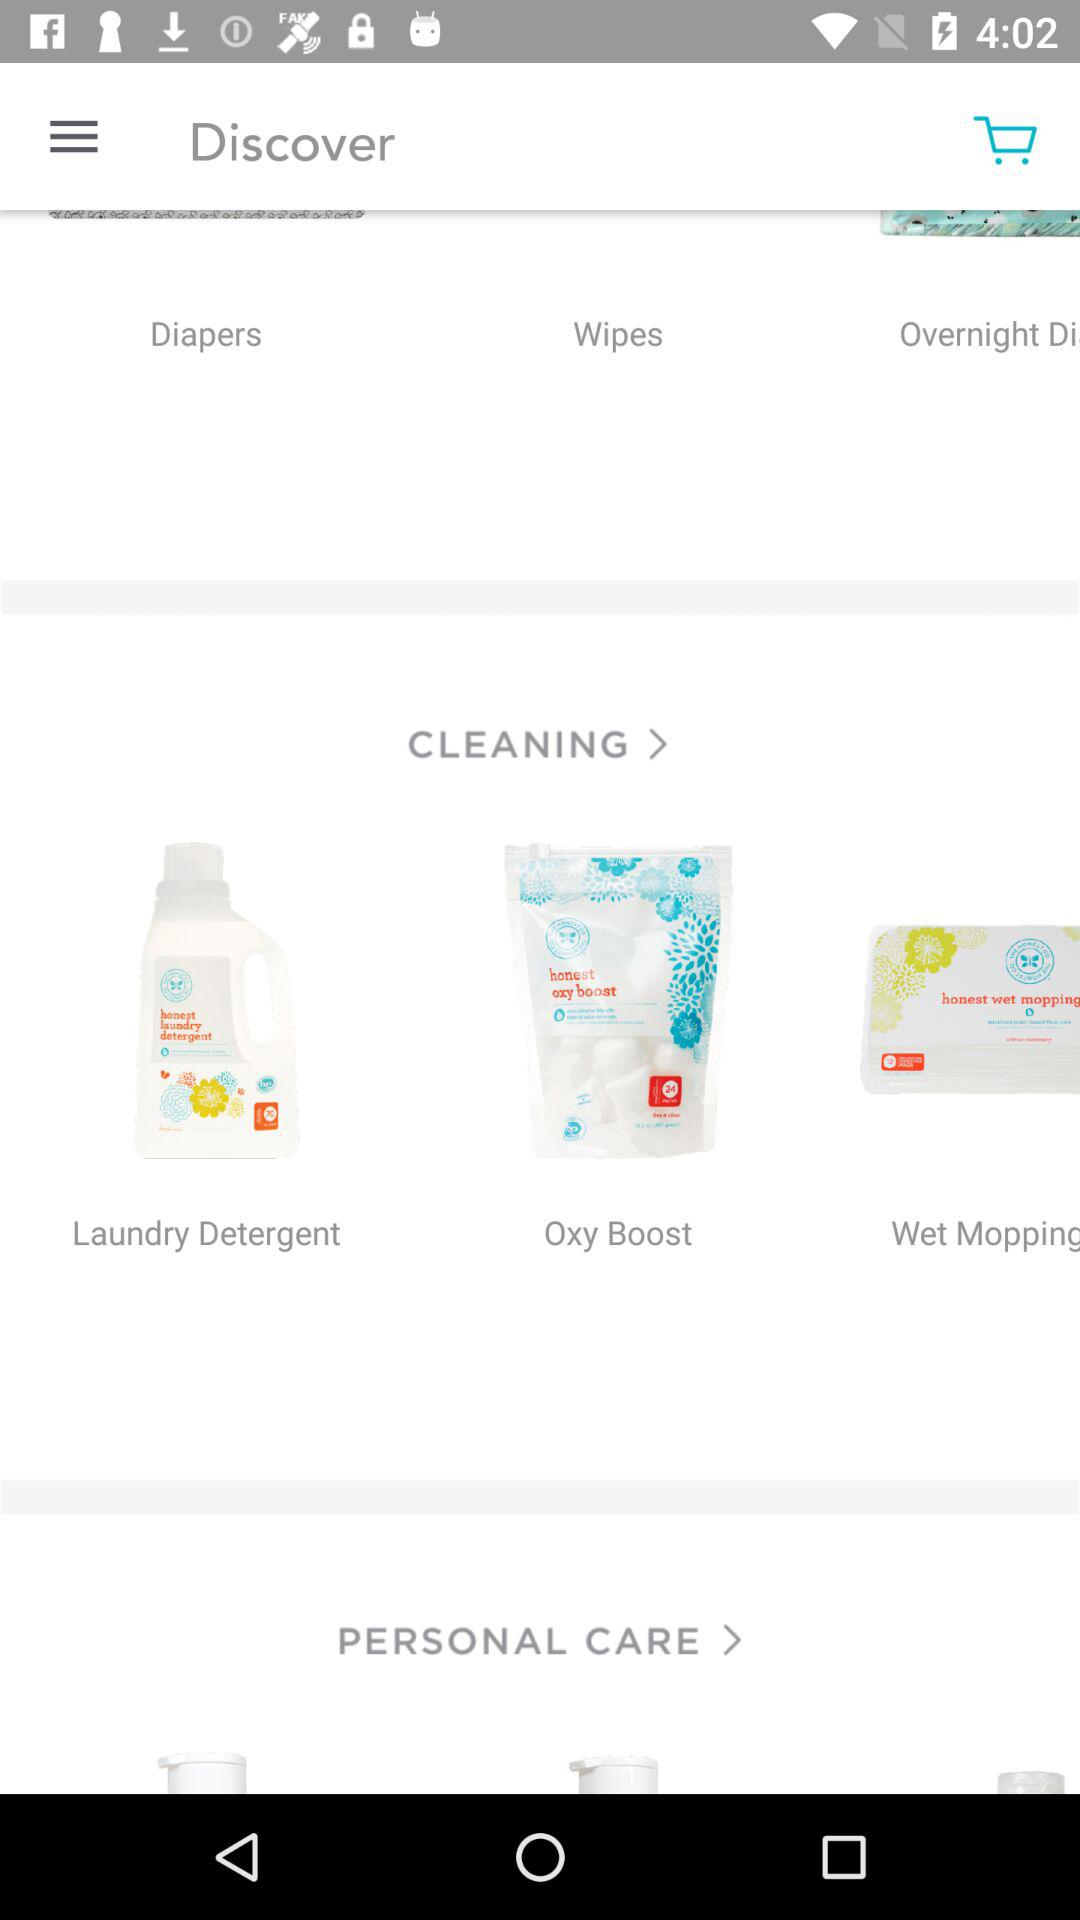How many items are in the cleaning category?
Answer the question using a single word or phrase. 3 